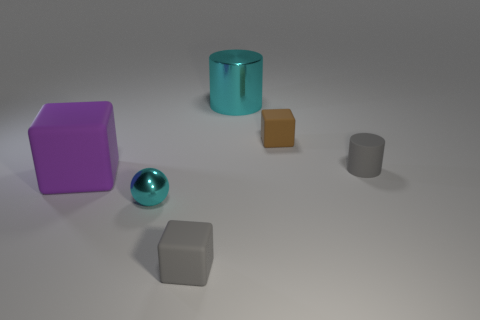Subtract all gray cylinders. Subtract all yellow blocks. How many cylinders are left? 1 Add 3 metallic cylinders. How many objects exist? 9 Subtract all cylinders. How many objects are left? 4 Subtract 0 purple balls. How many objects are left? 6 Subtract all shiny spheres. Subtract all cyan things. How many objects are left? 3 Add 5 large rubber objects. How many large rubber objects are left? 6 Add 6 small brown rubber spheres. How many small brown rubber spheres exist? 6 